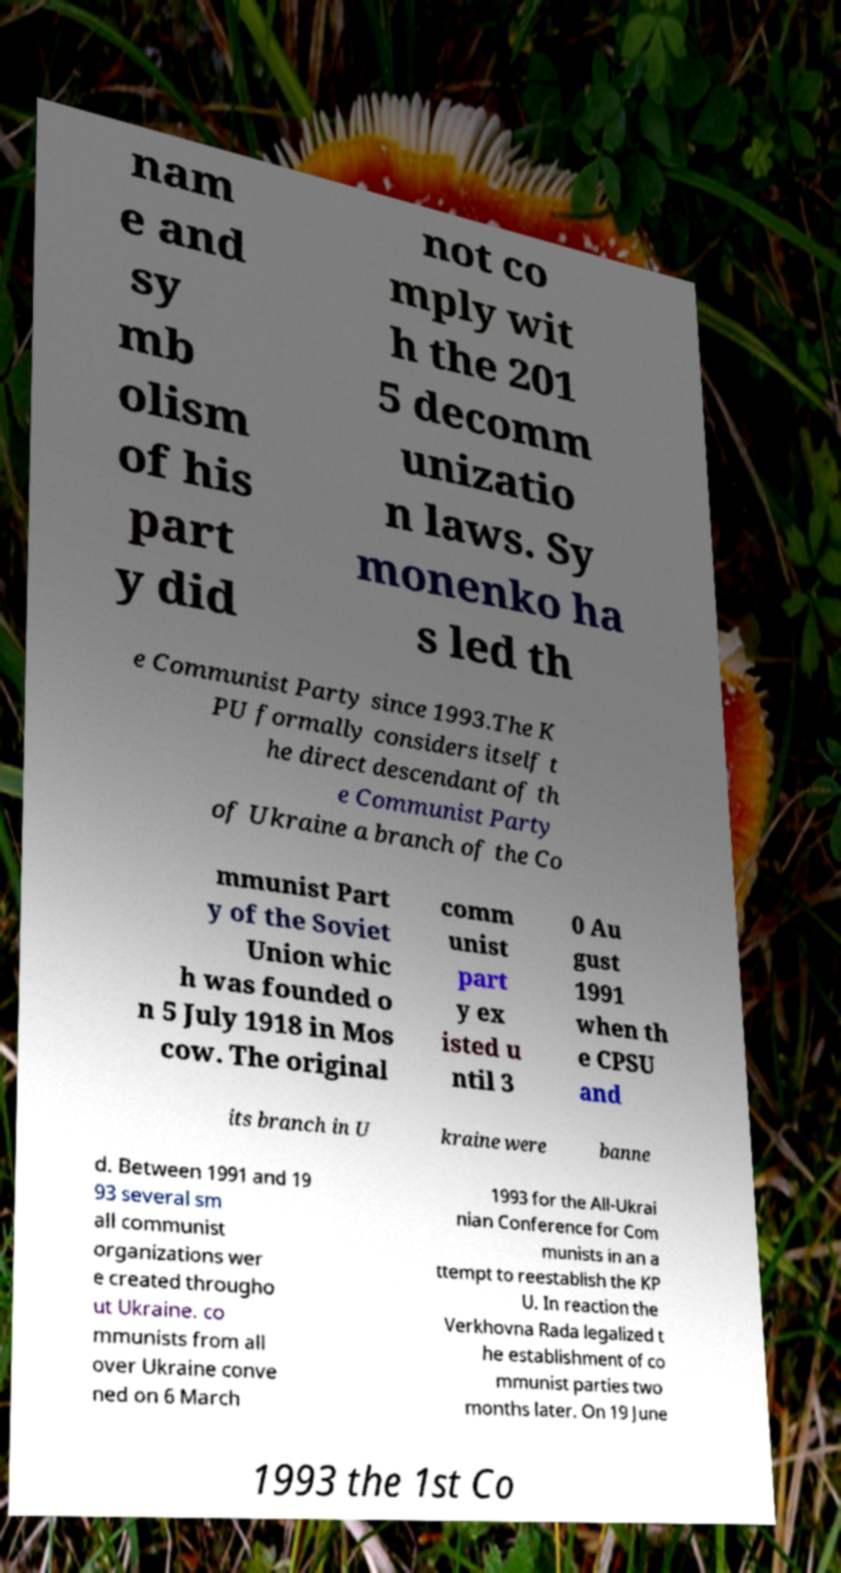Please read and relay the text visible in this image. What does it say? nam e and sy mb olism of his part y did not co mply wit h the 201 5 decomm unizatio n laws. Sy monenko ha s led th e Communist Party since 1993.The K PU formally considers itself t he direct descendant of th e Communist Party of Ukraine a branch of the Co mmunist Part y of the Soviet Union whic h was founded o n 5 July 1918 in Mos cow. The original comm unist part y ex isted u ntil 3 0 Au gust 1991 when th e CPSU and its branch in U kraine were banne d. Between 1991 and 19 93 several sm all communist organizations wer e created througho ut Ukraine. co mmunists from all over Ukraine conve ned on 6 March 1993 for the All-Ukrai nian Conference for Com munists in an a ttempt to reestablish the KP U. In reaction the Verkhovna Rada legalized t he establishment of co mmunist parties two months later. On 19 June 1993 the 1st Co 